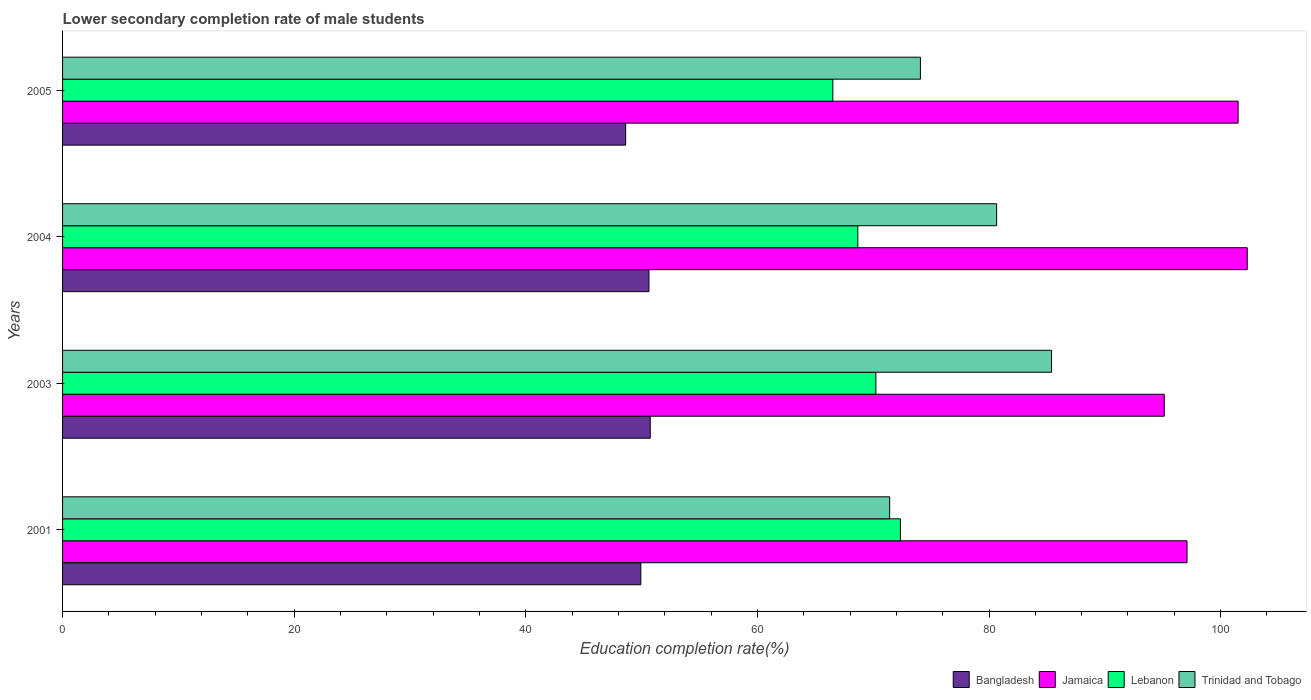How many groups of bars are there?
Keep it short and to the point. 4. Are the number of bars on each tick of the Y-axis equal?
Your response must be concise. Yes. How many bars are there on the 1st tick from the top?
Keep it short and to the point. 4. In how many cases, is the number of bars for a given year not equal to the number of legend labels?
Ensure brevity in your answer.  0. What is the lower secondary completion rate of male students in Bangladesh in 2004?
Provide a succinct answer. 50.63. Across all years, what is the maximum lower secondary completion rate of male students in Jamaica?
Make the answer very short. 102.3. Across all years, what is the minimum lower secondary completion rate of male students in Trinidad and Tobago?
Your response must be concise. 71.42. In which year was the lower secondary completion rate of male students in Trinidad and Tobago minimum?
Keep it short and to the point. 2001. What is the total lower secondary completion rate of male students in Trinidad and Tobago in the graph?
Offer a very short reply. 311.56. What is the difference between the lower secondary completion rate of male students in Trinidad and Tobago in 2001 and that in 2004?
Provide a succinct answer. -9.24. What is the difference between the lower secondary completion rate of male students in Jamaica in 2001 and the lower secondary completion rate of male students in Bangladesh in 2003?
Your answer should be very brief. 46.35. What is the average lower secondary completion rate of male students in Jamaica per year?
Provide a short and direct response. 99.01. In the year 2001, what is the difference between the lower secondary completion rate of male students in Jamaica and lower secondary completion rate of male students in Bangladesh?
Make the answer very short. 47.17. In how many years, is the lower secondary completion rate of male students in Trinidad and Tobago greater than 96 %?
Offer a very short reply. 0. What is the ratio of the lower secondary completion rate of male students in Jamaica in 2001 to that in 2004?
Ensure brevity in your answer.  0.95. Is the lower secondary completion rate of male students in Jamaica in 2003 less than that in 2005?
Keep it short and to the point. Yes. What is the difference between the highest and the second highest lower secondary completion rate of male students in Trinidad and Tobago?
Keep it short and to the point. 4.74. What is the difference between the highest and the lowest lower secondary completion rate of male students in Trinidad and Tobago?
Your answer should be very brief. 13.98. Is it the case that in every year, the sum of the lower secondary completion rate of male students in Bangladesh and lower secondary completion rate of male students in Trinidad and Tobago is greater than the sum of lower secondary completion rate of male students in Lebanon and lower secondary completion rate of male students in Jamaica?
Provide a short and direct response. Yes. What does the 4th bar from the top in 2003 represents?
Your response must be concise. Bangladesh. How many bars are there?
Keep it short and to the point. 16. Are all the bars in the graph horizontal?
Give a very brief answer. Yes. What is the difference between two consecutive major ticks on the X-axis?
Your answer should be compact. 20. Are the values on the major ticks of X-axis written in scientific E-notation?
Offer a terse response. No. Where does the legend appear in the graph?
Your answer should be very brief. Bottom right. How many legend labels are there?
Keep it short and to the point. 4. How are the legend labels stacked?
Give a very brief answer. Horizontal. What is the title of the graph?
Your answer should be very brief. Lower secondary completion rate of male students. Does "Russian Federation" appear as one of the legend labels in the graph?
Your response must be concise. No. What is the label or title of the X-axis?
Your response must be concise. Education completion rate(%). What is the label or title of the Y-axis?
Give a very brief answer. Years. What is the Education completion rate(%) of Bangladesh in 2001?
Your answer should be very brief. 49.93. What is the Education completion rate(%) in Jamaica in 2001?
Offer a terse response. 97.1. What is the Education completion rate(%) of Lebanon in 2001?
Provide a short and direct response. 72.35. What is the Education completion rate(%) in Trinidad and Tobago in 2001?
Your answer should be very brief. 71.42. What is the Education completion rate(%) of Bangladesh in 2003?
Offer a very short reply. 50.75. What is the Education completion rate(%) in Jamaica in 2003?
Provide a succinct answer. 95.13. What is the Education completion rate(%) in Lebanon in 2003?
Ensure brevity in your answer.  70.23. What is the Education completion rate(%) in Trinidad and Tobago in 2003?
Provide a succinct answer. 85.4. What is the Education completion rate(%) of Bangladesh in 2004?
Offer a terse response. 50.63. What is the Education completion rate(%) in Jamaica in 2004?
Make the answer very short. 102.3. What is the Education completion rate(%) in Lebanon in 2004?
Give a very brief answer. 68.67. What is the Education completion rate(%) of Trinidad and Tobago in 2004?
Provide a short and direct response. 80.66. What is the Education completion rate(%) of Bangladesh in 2005?
Provide a short and direct response. 48.62. What is the Education completion rate(%) of Jamaica in 2005?
Ensure brevity in your answer.  101.51. What is the Education completion rate(%) of Lebanon in 2005?
Provide a succinct answer. 66.51. What is the Education completion rate(%) of Trinidad and Tobago in 2005?
Offer a very short reply. 74.08. Across all years, what is the maximum Education completion rate(%) of Bangladesh?
Your response must be concise. 50.75. Across all years, what is the maximum Education completion rate(%) in Jamaica?
Your answer should be compact. 102.3. Across all years, what is the maximum Education completion rate(%) in Lebanon?
Keep it short and to the point. 72.35. Across all years, what is the maximum Education completion rate(%) of Trinidad and Tobago?
Your answer should be very brief. 85.4. Across all years, what is the minimum Education completion rate(%) in Bangladesh?
Ensure brevity in your answer.  48.62. Across all years, what is the minimum Education completion rate(%) of Jamaica?
Make the answer very short. 95.13. Across all years, what is the minimum Education completion rate(%) of Lebanon?
Keep it short and to the point. 66.51. Across all years, what is the minimum Education completion rate(%) of Trinidad and Tobago?
Provide a short and direct response. 71.42. What is the total Education completion rate(%) in Bangladesh in the graph?
Keep it short and to the point. 199.94. What is the total Education completion rate(%) of Jamaica in the graph?
Offer a very short reply. 396.04. What is the total Education completion rate(%) in Lebanon in the graph?
Your answer should be compact. 277.77. What is the total Education completion rate(%) in Trinidad and Tobago in the graph?
Give a very brief answer. 311.56. What is the difference between the Education completion rate(%) of Bangladesh in 2001 and that in 2003?
Offer a very short reply. -0.81. What is the difference between the Education completion rate(%) in Jamaica in 2001 and that in 2003?
Keep it short and to the point. 1.97. What is the difference between the Education completion rate(%) of Lebanon in 2001 and that in 2003?
Offer a very short reply. 2.12. What is the difference between the Education completion rate(%) in Trinidad and Tobago in 2001 and that in 2003?
Your response must be concise. -13.98. What is the difference between the Education completion rate(%) in Bangladesh in 2001 and that in 2004?
Offer a very short reply. -0.7. What is the difference between the Education completion rate(%) of Lebanon in 2001 and that in 2004?
Your response must be concise. 3.68. What is the difference between the Education completion rate(%) in Trinidad and Tobago in 2001 and that in 2004?
Offer a very short reply. -9.24. What is the difference between the Education completion rate(%) in Bangladesh in 2001 and that in 2005?
Offer a very short reply. 1.31. What is the difference between the Education completion rate(%) of Jamaica in 2001 and that in 2005?
Offer a very short reply. -4.41. What is the difference between the Education completion rate(%) of Lebanon in 2001 and that in 2005?
Your answer should be very brief. 5.84. What is the difference between the Education completion rate(%) of Trinidad and Tobago in 2001 and that in 2005?
Your answer should be compact. -2.66. What is the difference between the Education completion rate(%) in Bangladesh in 2003 and that in 2004?
Give a very brief answer. 0.11. What is the difference between the Education completion rate(%) in Jamaica in 2003 and that in 2004?
Keep it short and to the point. -7.17. What is the difference between the Education completion rate(%) of Lebanon in 2003 and that in 2004?
Offer a very short reply. 1.56. What is the difference between the Education completion rate(%) of Trinidad and Tobago in 2003 and that in 2004?
Give a very brief answer. 4.74. What is the difference between the Education completion rate(%) of Bangladesh in 2003 and that in 2005?
Ensure brevity in your answer.  2.12. What is the difference between the Education completion rate(%) in Jamaica in 2003 and that in 2005?
Make the answer very short. -6.38. What is the difference between the Education completion rate(%) in Lebanon in 2003 and that in 2005?
Ensure brevity in your answer.  3.72. What is the difference between the Education completion rate(%) of Trinidad and Tobago in 2003 and that in 2005?
Give a very brief answer. 11.32. What is the difference between the Education completion rate(%) in Bangladesh in 2004 and that in 2005?
Offer a very short reply. 2.01. What is the difference between the Education completion rate(%) in Jamaica in 2004 and that in 2005?
Ensure brevity in your answer.  0.79. What is the difference between the Education completion rate(%) of Lebanon in 2004 and that in 2005?
Provide a succinct answer. 2.16. What is the difference between the Education completion rate(%) of Trinidad and Tobago in 2004 and that in 2005?
Ensure brevity in your answer.  6.58. What is the difference between the Education completion rate(%) of Bangladesh in 2001 and the Education completion rate(%) of Jamaica in 2003?
Your answer should be compact. -45.2. What is the difference between the Education completion rate(%) of Bangladesh in 2001 and the Education completion rate(%) of Lebanon in 2003?
Provide a succinct answer. -20.3. What is the difference between the Education completion rate(%) in Bangladesh in 2001 and the Education completion rate(%) in Trinidad and Tobago in 2003?
Ensure brevity in your answer.  -35.47. What is the difference between the Education completion rate(%) of Jamaica in 2001 and the Education completion rate(%) of Lebanon in 2003?
Your response must be concise. 26.87. What is the difference between the Education completion rate(%) of Jamaica in 2001 and the Education completion rate(%) of Trinidad and Tobago in 2003?
Provide a succinct answer. 11.7. What is the difference between the Education completion rate(%) of Lebanon in 2001 and the Education completion rate(%) of Trinidad and Tobago in 2003?
Your answer should be compact. -13.05. What is the difference between the Education completion rate(%) in Bangladesh in 2001 and the Education completion rate(%) in Jamaica in 2004?
Offer a terse response. -52.37. What is the difference between the Education completion rate(%) in Bangladesh in 2001 and the Education completion rate(%) in Lebanon in 2004?
Offer a terse response. -18.74. What is the difference between the Education completion rate(%) in Bangladesh in 2001 and the Education completion rate(%) in Trinidad and Tobago in 2004?
Offer a terse response. -30.72. What is the difference between the Education completion rate(%) of Jamaica in 2001 and the Education completion rate(%) of Lebanon in 2004?
Ensure brevity in your answer.  28.43. What is the difference between the Education completion rate(%) in Jamaica in 2001 and the Education completion rate(%) in Trinidad and Tobago in 2004?
Offer a very short reply. 16.44. What is the difference between the Education completion rate(%) of Lebanon in 2001 and the Education completion rate(%) of Trinidad and Tobago in 2004?
Offer a very short reply. -8.31. What is the difference between the Education completion rate(%) of Bangladesh in 2001 and the Education completion rate(%) of Jamaica in 2005?
Provide a succinct answer. -51.58. What is the difference between the Education completion rate(%) in Bangladesh in 2001 and the Education completion rate(%) in Lebanon in 2005?
Ensure brevity in your answer.  -16.58. What is the difference between the Education completion rate(%) of Bangladesh in 2001 and the Education completion rate(%) of Trinidad and Tobago in 2005?
Provide a short and direct response. -24.14. What is the difference between the Education completion rate(%) of Jamaica in 2001 and the Education completion rate(%) of Lebanon in 2005?
Make the answer very short. 30.59. What is the difference between the Education completion rate(%) in Jamaica in 2001 and the Education completion rate(%) in Trinidad and Tobago in 2005?
Provide a succinct answer. 23.02. What is the difference between the Education completion rate(%) in Lebanon in 2001 and the Education completion rate(%) in Trinidad and Tobago in 2005?
Provide a succinct answer. -1.73. What is the difference between the Education completion rate(%) in Bangladesh in 2003 and the Education completion rate(%) in Jamaica in 2004?
Give a very brief answer. -51.55. What is the difference between the Education completion rate(%) of Bangladesh in 2003 and the Education completion rate(%) of Lebanon in 2004?
Provide a short and direct response. -17.93. What is the difference between the Education completion rate(%) of Bangladesh in 2003 and the Education completion rate(%) of Trinidad and Tobago in 2004?
Keep it short and to the point. -29.91. What is the difference between the Education completion rate(%) in Jamaica in 2003 and the Education completion rate(%) in Lebanon in 2004?
Your answer should be very brief. 26.46. What is the difference between the Education completion rate(%) in Jamaica in 2003 and the Education completion rate(%) in Trinidad and Tobago in 2004?
Ensure brevity in your answer.  14.47. What is the difference between the Education completion rate(%) of Lebanon in 2003 and the Education completion rate(%) of Trinidad and Tobago in 2004?
Make the answer very short. -10.43. What is the difference between the Education completion rate(%) in Bangladesh in 2003 and the Education completion rate(%) in Jamaica in 2005?
Provide a short and direct response. -50.76. What is the difference between the Education completion rate(%) of Bangladesh in 2003 and the Education completion rate(%) of Lebanon in 2005?
Ensure brevity in your answer.  -15.77. What is the difference between the Education completion rate(%) in Bangladesh in 2003 and the Education completion rate(%) in Trinidad and Tobago in 2005?
Make the answer very short. -23.33. What is the difference between the Education completion rate(%) in Jamaica in 2003 and the Education completion rate(%) in Lebanon in 2005?
Provide a short and direct response. 28.62. What is the difference between the Education completion rate(%) in Jamaica in 2003 and the Education completion rate(%) in Trinidad and Tobago in 2005?
Provide a short and direct response. 21.06. What is the difference between the Education completion rate(%) of Lebanon in 2003 and the Education completion rate(%) of Trinidad and Tobago in 2005?
Keep it short and to the point. -3.85. What is the difference between the Education completion rate(%) in Bangladesh in 2004 and the Education completion rate(%) in Jamaica in 2005?
Give a very brief answer. -50.88. What is the difference between the Education completion rate(%) of Bangladesh in 2004 and the Education completion rate(%) of Lebanon in 2005?
Keep it short and to the point. -15.88. What is the difference between the Education completion rate(%) in Bangladesh in 2004 and the Education completion rate(%) in Trinidad and Tobago in 2005?
Provide a succinct answer. -23.44. What is the difference between the Education completion rate(%) in Jamaica in 2004 and the Education completion rate(%) in Lebanon in 2005?
Ensure brevity in your answer.  35.79. What is the difference between the Education completion rate(%) of Jamaica in 2004 and the Education completion rate(%) of Trinidad and Tobago in 2005?
Offer a very short reply. 28.22. What is the difference between the Education completion rate(%) in Lebanon in 2004 and the Education completion rate(%) in Trinidad and Tobago in 2005?
Your answer should be compact. -5.4. What is the average Education completion rate(%) of Bangladesh per year?
Your answer should be compact. 49.98. What is the average Education completion rate(%) of Jamaica per year?
Give a very brief answer. 99.01. What is the average Education completion rate(%) of Lebanon per year?
Provide a succinct answer. 69.44. What is the average Education completion rate(%) of Trinidad and Tobago per year?
Ensure brevity in your answer.  77.89. In the year 2001, what is the difference between the Education completion rate(%) in Bangladesh and Education completion rate(%) in Jamaica?
Offer a terse response. -47.17. In the year 2001, what is the difference between the Education completion rate(%) of Bangladesh and Education completion rate(%) of Lebanon?
Keep it short and to the point. -22.42. In the year 2001, what is the difference between the Education completion rate(%) in Bangladesh and Education completion rate(%) in Trinidad and Tobago?
Offer a very short reply. -21.49. In the year 2001, what is the difference between the Education completion rate(%) of Jamaica and Education completion rate(%) of Lebanon?
Provide a succinct answer. 24.75. In the year 2001, what is the difference between the Education completion rate(%) of Jamaica and Education completion rate(%) of Trinidad and Tobago?
Give a very brief answer. 25.68. In the year 2001, what is the difference between the Education completion rate(%) of Lebanon and Education completion rate(%) of Trinidad and Tobago?
Make the answer very short. 0.93. In the year 2003, what is the difference between the Education completion rate(%) in Bangladesh and Education completion rate(%) in Jamaica?
Your answer should be very brief. -44.39. In the year 2003, what is the difference between the Education completion rate(%) in Bangladesh and Education completion rate(%) in Lebanon?
Offer a terse response. -19.48. In the year 2003, what is the difference between the Education completion rate(%) of Bangladesh and Education completion rate(%) of Trinidad and Tobago?
Provide a short and direct response. -34.65. In the year 2003, what is the difference between the Education completion rate(%) in Jamaica and Education completion rate(%) in Lebanon?
Your answer should be very brief. 24.9. In the year 2003, what is the difference between the Education completion rate(%) of Jamaica and Education completion rate(%) of Trinidad and Tobago?
Keep it short and to the point. 9.73. In the year 2003, what is the difference between the Education completion rate(%) of Lebanon and Education completion rate(%) of Trinidad and Tobago?
Keep it short and to the point. -15.17. In the year 2004, what is the difference between the Education completion rate(%) in Bangladesh and Education completion rate(%) in Jamaica?
Provide a short and direct response. -51.66. In the year 2004, what is the difference between the Education completion rate(%) of Bangladesh and Education completion rate(%) of Lebanon?
Give a very brief answer. -18.04. In the year 2004, what is the difference between the Education completion rate(%) of Bangladesh and Education completion rate(%) of Trinidad and Tobago?
Your answer should be very brief. -30.02. In the year 2004, what is the difference between the Education completion rate(%) in Jamaica and Education completion rate(%) in Lebanon?
Ensure brevity in your answer.  33.63. In the year 2004, what is the difference between the Education completion rate(%) of Jamaica and Education completion rate(%) of Trinidad and Tobago?
Offer a very short reply. 21.64. In the year 2004, what is the difference between the Education completion rate(%) of Lebanon and Education completion rate(%) of Trinidad and Tobago?
Offer a terse response. -11.99. In the year 2005, what is the difference between the Education completion rate(%) of Bangladesh and Education completion rate(%) of Jamaica?
Ensure brevity in your answer.  -52.89. In the year 2005, what is the difference between the Education completion rate(%) in Bangladesh and Education completion rate(%) in Lebanon?
Ensure brevity in your answer.  -17.89. In the year 2005, what is the difference between the Education completion rate(%) of Bangladesh and Education completion rate(%) of Trinidad and Tobago?
Ensure brevity in your answer.  -25.45. In the year 2005, what is the difference between the Education completion rate(%) in Jamaica and Education completion rate(%) in Lebanon?
Keep it short and to the point. 35. In the year 2005, what is the difference between the Education completion rate(%) of Jamaica and Education completion rate(%) of Trinidad and Tobago?
Make the answer very short. 27.43. In the year 2005, what is the difference between the Education completion rate(%) in Lebanon and Education completion rate(%) in Trinidad and Tobago?
Offer a terse response. -7.56. What is the ratio of the Education completion rate(%) of Jamaica in 2001 to that in 2003?
Provide a short and direct response. 1.02. What is the ratio of the Education completion rate(%) in Lebanon in 2001 to that in 2003?
Offer a terse response. 1.03. What is the ratio of the Education completion rate(%) of Trinidad and Tobago in 2001 to that in 2003?
Provide a short and direct response. 0.84. What is the ratio of the Education completion rate(%) in Bangladesh in 2001 to that in 2004?
Your answer should be compact. 0.99. What is the ratio of the Education completion rate(%) of Jamaica in 2001 to that in 2004?
Ensure brevity in your answer.  0.95. What is the ratio of the Education completion rate(%) in Lebanon in 2001 to that in 2004?
Give a very brief answer. 1.05. What is the ratio of the Education completion rate(%) of Trinidad and Tobago in 2001 to that in 2004?
Provide a succinct answer. 0.89. What is the ratio of the Education completion rate(%) of Bangladesh in 2001 to that in 2005?
Your answer should be very brief. 1.03. What is the ratio of the Education completion rate(%) of Jamaica in 2001 to that in 2005?
Give a very brief answer. 0.96. What is the ratio of the Education completion rate(%) in Lebanon in 2001 to that in 2005?
Keep it short and to the point. 1.09. What is the ratio of the Education completion rate(%) in Trinidad and Tobago in 2001 to that in 2005?
Your answer should be compact. 0.96. What is the ratio of the Education completion rate(%) in Bangladesh in 2003 to that in 2004?
Keep it short and to the point. 1. What is the ratio of the Education completion rate(%) of Jamaica in 2003 to that in 2004?
Offer a terse response. 0.93. What is the ratio of the Education completion rate(%) in Lebanon in 2003 to that in 2004?
Offer a terse response. 1.02. What is the ratio of the Education completion rate(%) in Trinidad and Tobago in 2003 to that in 2004?
Give a very brief answer. 1.06. What is the ratio of the Education completion rate(%) of Bangladesh in 2003 to that in 2005?
Make the answer very short. 1.04. What is the ratio of the Education completion rate(%) of Jamaica in 2003 to that in 2005?
Your response must be concise. 0.94. What is the ratio of the Education completion rate(%) in Lebanon in 2003 to that in 2005?
Ensure brevity in your answer.  1.06. What is the ratio of the Education completion rate(%) of Trinidad and Tobago in 2003 to that in 2005?
Your answer should be compact. 1.15. What is the ratio of the Education completion rate(%) of Bangladesh in 2004 to that in 2005?
Your answer should be compact. 1.04. What is the ratio of the Education completion rate(%) in Lebanon in 2004 to that in 2005?
Your answer should be compact. 1.03. What is the ratio of the Education completion rate(%) in Trinidad and Tobago in 2004 to that in 2005?
Offer a terse response. 1.09. What is the difference between the highest and the second highest Education completion rate(%) of Bangladesh?
Your response must be concise. 0.11. What is the difference between the highest and the second highest Education completion rate(%) of Jamaica?
Ensure brevity in your answer.  0.79. What is the difference between the highest and the second highest Education completion rate(%) in Lebanon?
Give a very brief answer. 2.12. What is the difference between the highest and the second highest Education completion rate(%) of Trinidad and Tobago?
Make the answer very short. 4.74. What is the difference between the highest and the lowest Education completion rate(%) in Bangladesh?
Your response must be concise. 2.12. What is the difference between the highest and the lowest Education completion rate(%) of Jamaica?
Provide a short and direct response. 7.17. What is the difference between the highest and the lowest Education completion rate(%) in Lebanon?
Offer a very short reply. 5.84. What is the difference between the highest and the lowest Education completion rate(%) of Trinidad and Tobago?
Make the answer very short. 13.98. 